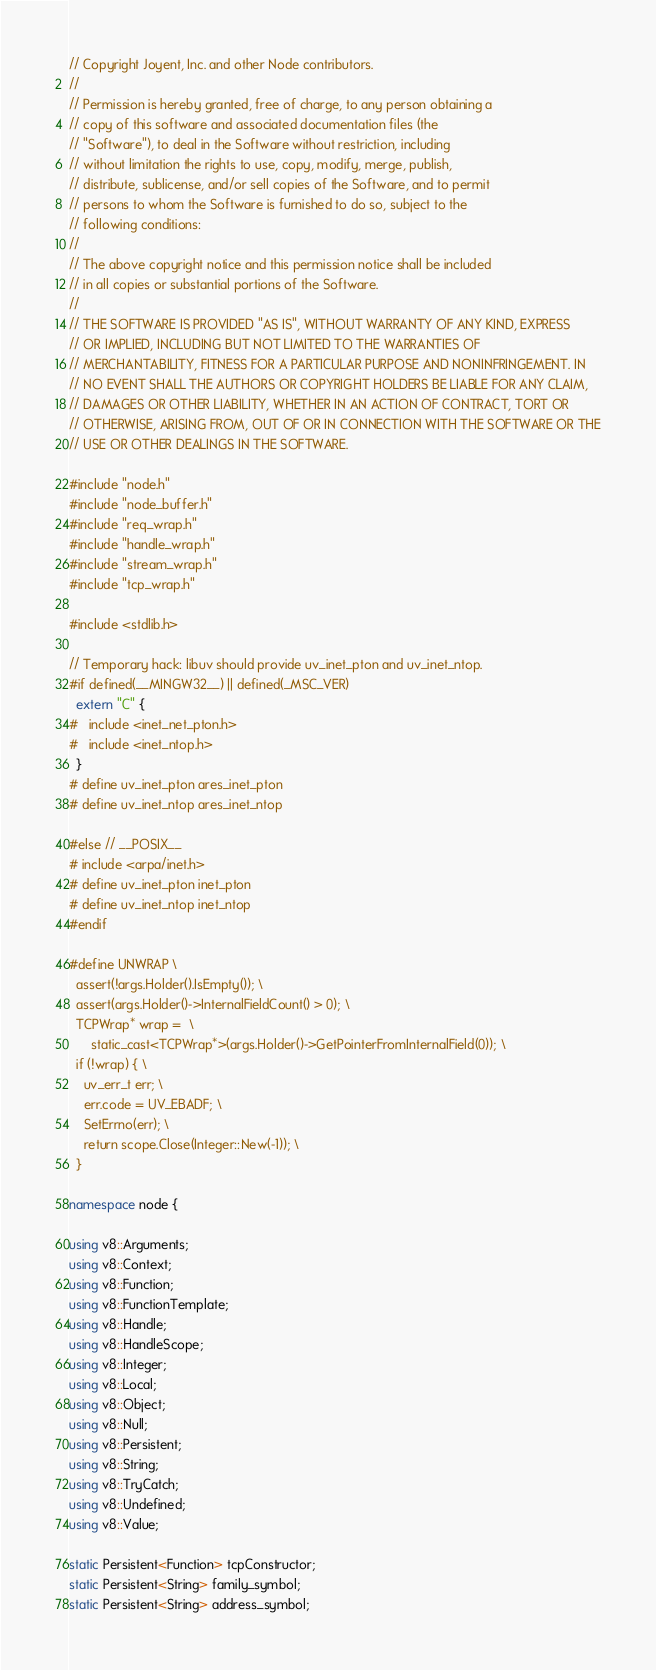Convert code to text. <code><loc_0><loc_0><loc_500><loc_500><_C++_>// Copyright Joyent, Inc. and other Node contributors.
//
// Permission is hereby granted, free of charge, to any person obtaining a
// copy of this software and associated documentation files (the
// "Software"), to deal in the Software without restriction, including
// without limitation the rights to use, copy, modify, merge, publish,
// distribute, sublicense, and/or sell copies of the Software, and to permit
// persons to whom the Software is furnished to do so, subject to the
// following conditions:
//
// The above copyright notice and this permission notice shall be included
// in all copies or substantial portions of the Software.
//
// THE SOFTWARE IS PROVIDED "AS IS", WITHOUT WARRANTY OF ANY KIND, EXPRESS
// OR IMPLIED, INCLUDING BUT NOT LIMITED TO THE WARRANTIES OF
// MERCHANTABILITY, FITNESS FOR A PARTICULAR PURPOSE AND NONINFRINGEMENT. IN
// NO EVENT SHALL THE AUTHORS OR COPYRIGHT HOLDERS BE LIABLE FOR ANY CLAIM,
// DAMAGES OR OTHER LIABILITY, WHETHER IN AN ACTION OF CONTRACT, TORT OR
// OTHERWISE, ARISING FROM, OUT OF OR IN CONNECTION WITH THE SOFTWARE OR THE
// USE OR OTHER DEALINGS IN THE SOFTWARE.

#include "node.h"
#include "node_buffer.h"
#include "req_wrap.h"
#include "handle_wrap.h"
#include "stream_wrap.h"
#include "tcp_wrap.h"

#include <stdlib.h>

// Temporary hack: libuv should provide uv_inet_pton and uv_inet_ntop.
#if defined(__MINGW32__) || defined(_MSC_VER)
  extern "C" {
#   include <inet_net_pton.h>
#   include <inet_ntop.h>
  }
# define uv_inet_pton ares_inet_pton
# define uv_inet_ntop ares_inet_ntop

#else // __POSIX__
# include <arpa/inet.h>
# define uv_inet_pton inet_pton
# define uv_inet_ntop inet_ntop
#endif

#define UNWRAP \
  assert(!args.Holder().IsEmpty()); \
  assert(args.Holder()->InternalFieldCount() > 0); \
  TCPWrap* wrap =  \
      static_cast<TCPWrap*>(args.Holder()->GetPointerFromInternalField(0)); \
  if (!wrap) { \
    uv_err_t err; \
    err.code = UV_EBADF; \
    SetErrno(err); \
    return scope.Close(Integer::New(-1)); \
  }

namespace node {

using v8::Arguments;
using v8::Context;
using v8::Function;
using v8::FunctionTemplate;
using v8::Handle;
using v8::HandleScope;
using v8::Integer;
using v8::Local;
using v8::Object;
using v8::Null;
using v8::Persistent;
using v8::String;
using v8::TryCatch;
using v8::Undefined;
using v8::Value;

static Persistent<Function> tcpConstructor;
static Persistent<String> family_symbol;
static Persistent<String> address_symbol;</code> 